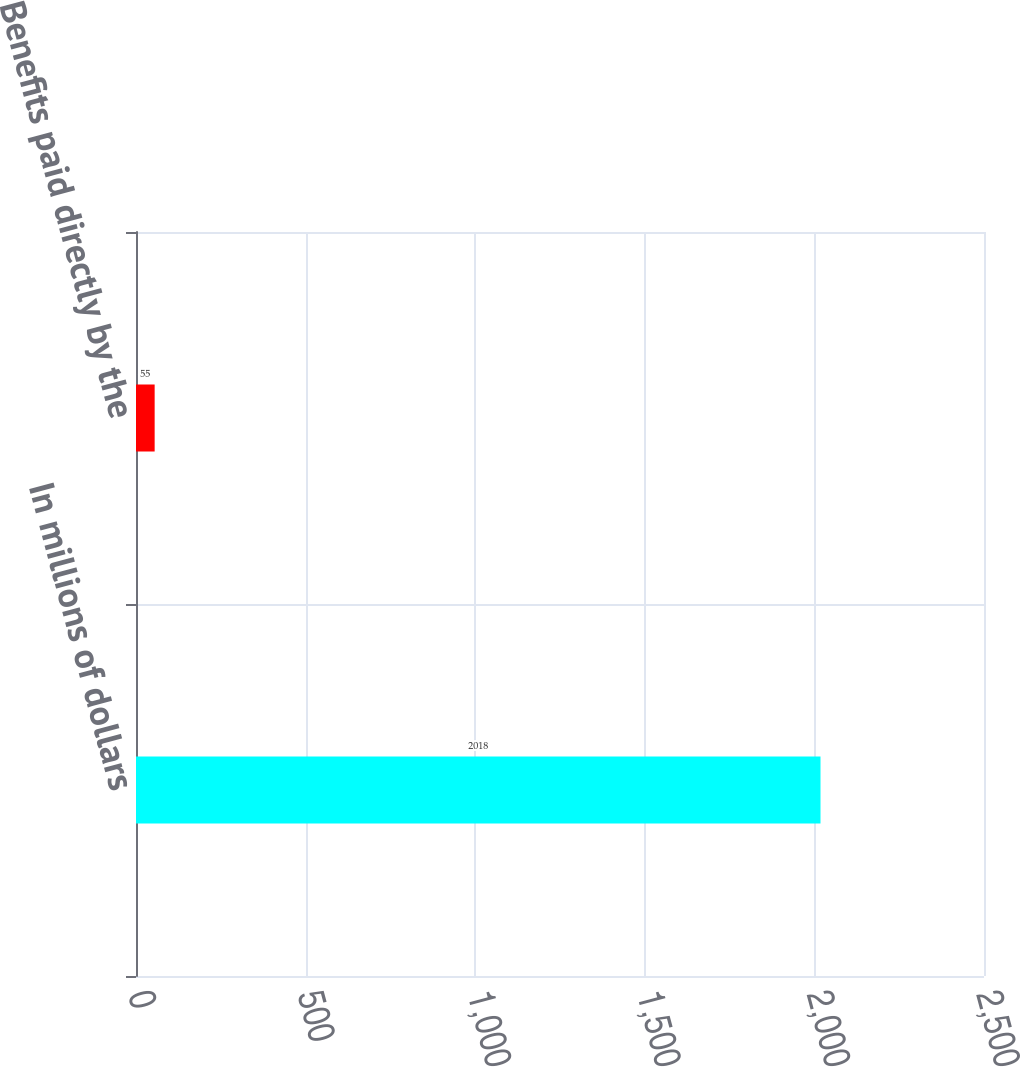Convert chart. <chart><loc_0><loc_0><loc_500><loc_500><bar_chart><fcel>In millions of dollars<fcel>Benefits paid directly by the<nl><fcel>2018<fcel>55<nl></chart> 